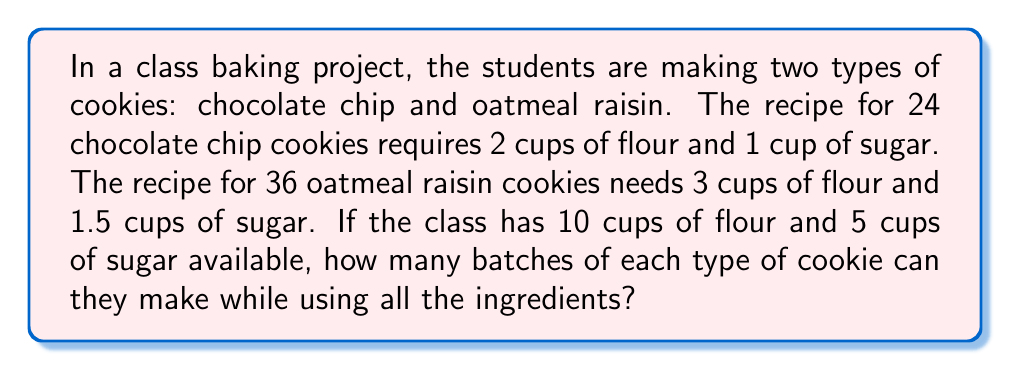Can you answer this question? Let's approach this step-by-step:

1) Let $x$ be the number of batches of chocolate chip cookies and $y$ be the number of batches of oatmeal raisin cookies.

2) For flour:
   - Each batch of chocolate chip cookies uses 2 cups
   - Each batch of oatmeal raisin cookies uses 3 cups
   - Total available is 10 cups
   This gives us the equation: $2x + 3y = 10$

3) For sugar:
   - Each batch of chocolate chip cookies uses 1 cup
   - Each batch of oatmeal raisin cookies uses 1.5 cups
   - Total available is 5 cups
   This gives us the equation: $x + 1.5y = 5$

4) Now we have a system of two equations:
   $$\begin{cases}
   2x + 3y = 10 \\
   x + 1.5y = 5
   \end{cases}$$

5) Multiply the second equation by 2:
   $$\begin{cases}
   2x + 3y = 10 \\
   2x + 3y = 10
   \end{cases}$$

6) Subtracting the second equation from the first:
   $0 = 0$

7) This means the equations are dependent, and there are infinite solutions along the line $x + 1.5y = 5$

8) However, we need whole number solutions for batches. Testing values:
   If $y = 2$, then $x = 2$
   This satisfies both equations: $2(2) + 3(2) = 10$ and $2 + 1.5(2) = 5$

Therefore, the class can make 2 batches of each type of cookie.
Answer: 2 batches of each type 